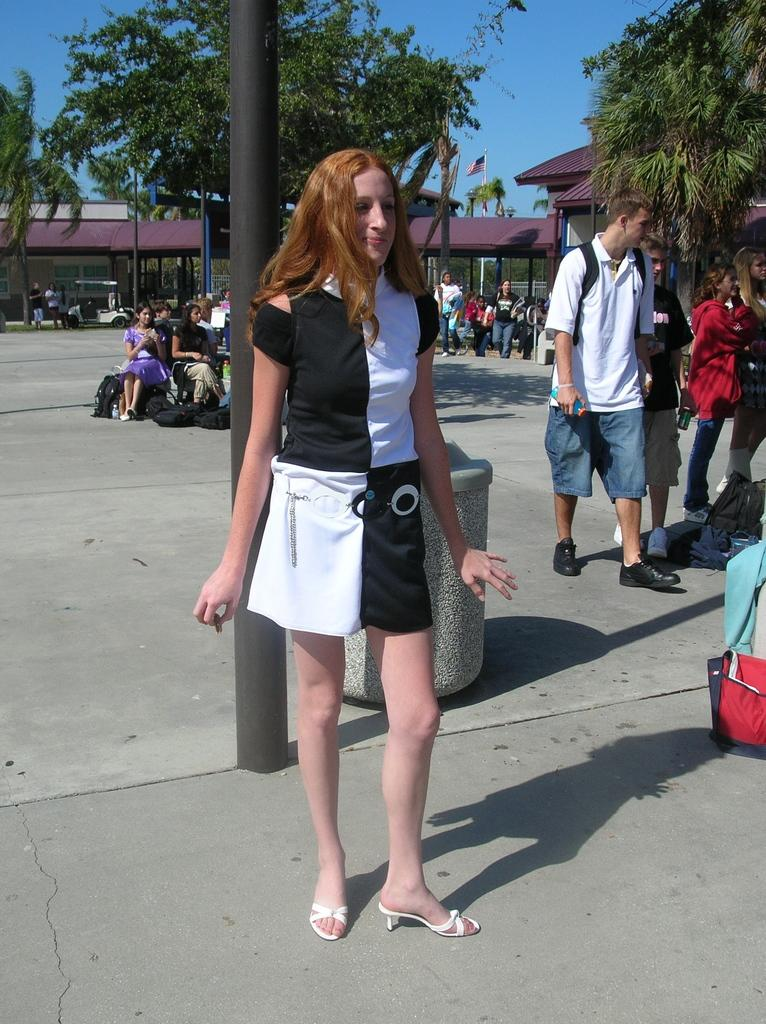Who is present in the image? There is a woman in the image. What is the woman wearing? The woman is wearing a black and white dress. What can be seen at the bottom of the image? There is a road at the bottom of the image. What is visible in the background of the image? There are trees in the background of the image. How many people are present in the image? There are many people in the image. What type of yak can be seen in the image? There is no yak present in the image. What color is the dirt on the road in the image? The image does not provide information about the color of the dirt on the road. 